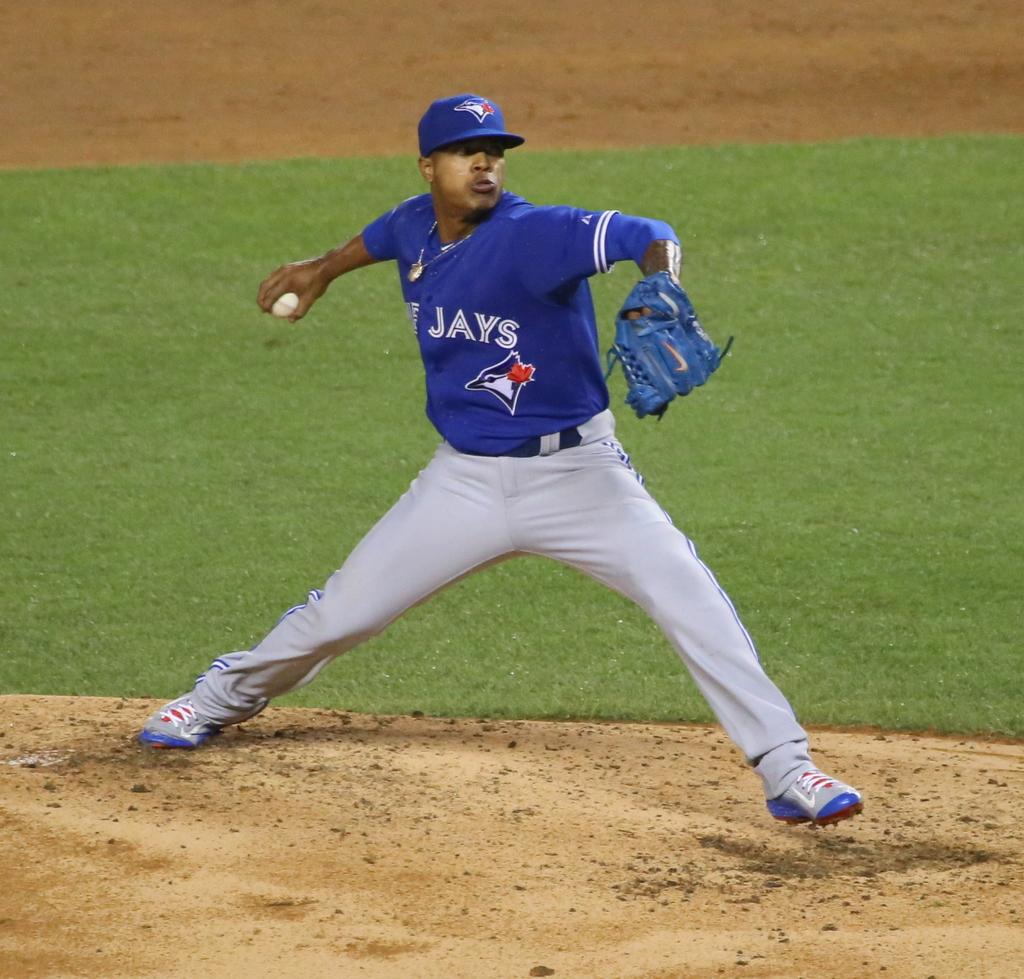What team does this man play for?
Your answer should be very brief. Blue jays. 